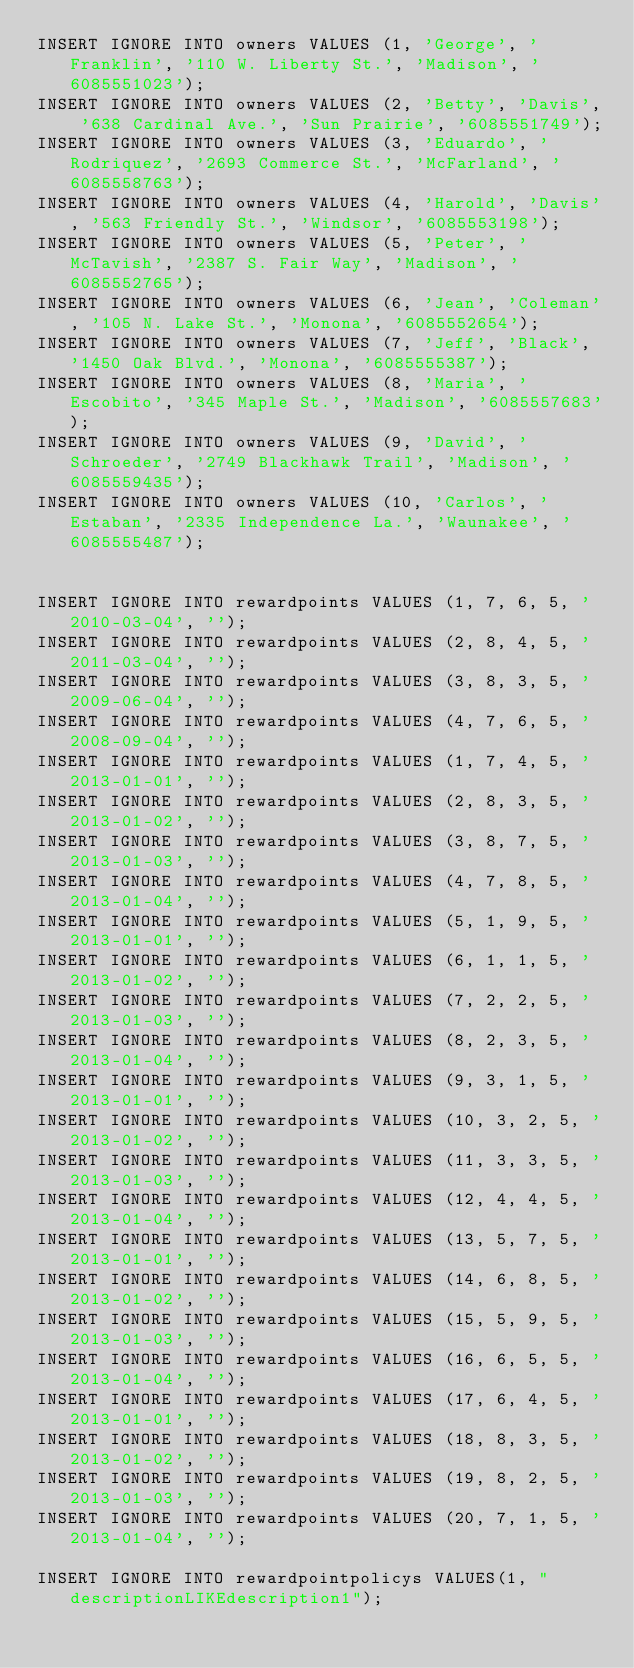<code> <loc_0><loc_0><loc_500><loc_500><_SQL_>INSERT IGNORE INTO owners VALUES (1, 'George', 'Franklin', '110 W. Liberty St.', 'Madison', '6085551023');
INSERT IGNORE INTO owners VALUES (2, 'Betty', 'Davis', '638 Cardinal Ave.', 'Sun Prairie', '6085551749');
INSERT IGNORE INTO owners VALUES (3, 'Eduardo', 'Rodriquez', '2693 Commerce St.', 'McFarland', '6085558763');
INSERT IGNORE INTO owners VALUES (4, 'Harold', 'Davis', '563 Friendly St.', 'Windsor', '6085553198');
INSERT IGNORE INTO owners VALUES (5, 'Peter', 'McTavish', '2387 S. Fair Way', 'Madison', '6085552765');
INSERT IGNORE INTO owners VALUES (6, 'Jean', 'Coleman', '105 N. Lake St.', 'Monona', '6085552654');
INSERT IGNORE INTO owners VALUES (7, 'Jeff', 'Black', '1450 Oak Blvd.', 'Monona', '6085555387');
INSERT IGNORE INTO owners VALUES (8, 'Maria', 'Escobito', '345 Maple St.', 'Madison', '6085557683');
INSERT IGNORE INTO owners VALUES (9, 'David', 'Schroeder', '2749 Blackhawk Trail', 'Madison', '6085559435');
INSERT IGNORE INTO owners VALUES (10, 'Carlos', 'Estaban', '2335 Independence La.', 'Waunakee', '6085555487');


INSERT IGNORE INTO rewardpoints VALUES (1, 7, 6, 5, '2010-03-04', '');
INSERT IGNORE INTO rewardpoints VALUES (2, 8, 4, 5, '2011-03-04', '');
INSERT IGNORE INTO rewardpoints VALUES (3, 8, 3, 5, '2009-06-04', '');
INSERT IGNORE INTO rewardpoints VALUES (4, 7, 6, 5, '2008-09-04', '');
INSERT IGNORE INTO rewardpoints VALUES (1, 7, 4, 5, '2013-01-01', '');
INSERT IGNORE INTO rewardpoints VALUES (2, 8, 3, 5, '2013-01-02', '');
INSERT IGNORE INTO rewardpoints VALUES (3, 8, 7, 5, '2013-01-03', '');
INSERT IGNORE INTO rewardpoints VALUES (4, 7, 8, 5, '2013-01-04', '');
INSERT IGNORE INTO rewardpoints VALUES (5, 1, 9, 5, '2013-01-01', '');
INSERT IGNORE INTO rewardpoints VALUES (6, 1, 1, 5, '2013-01-02', '');
INSERT IGNORE INTO rewardpoints VALUES (7, 2, 2, 5, '2013-01-03', '');
INSERT IGNORE INTO rewardpoints VALUES (8, 2, 3, 5, '2013-01-04', '');
INSERT IGNORE INTO rewardpoints VALUES (9, 3, 1, 5, '2013-01-01', '');
INSERT IGNORE INTO rewardpoints VALUES (10, 3, 2, 5, '2013-01-02', '');
INSERT IGNORE INTO rewardpoints VALUES (11, 3, 3, 5, '2013-01-03', '');
INSERT IGNORE INTO rewardpoints VALUES (12, 4, 4, 5, '2013-01-04', '');
INSERT IGNORE INTO rewardpoints VALUES (13, 5, 7, 5, '2013-01-01', '');
INSERT IGNORE INTO rewardpoints VALUES (14, 6, 8, 5, '2013-01-02', '');
INSERT IGNORE INTO rewardpoints VALUES (15, 5, 9, 5, '2013-01-03', '');
INSERT IGNORE INTO rewardpoints VALUES (16, 6, 5, 5, '2013-01-04', '');
INSERT IGNORE INTO rewardpoints VALUES (17, 6, 4, 5, '2013-01-01', '');
INSERT IGNORE INTO rewardpoints VALUES (18, 8, 3, 5, '2013-01-02', '');
INSERT IGNORE INTO rewardpoints VALUES (19, 8, 2, 5, '2013-01-03', '');
INSERT IGNORE INTO rewardpoints VALUES (20, 7, 1, 5, '2013-01-04', '');

INSERT IGNORE INTO rewardpointpolicys VALUES(1, "descriptionLIKEdescription1");
</code> 